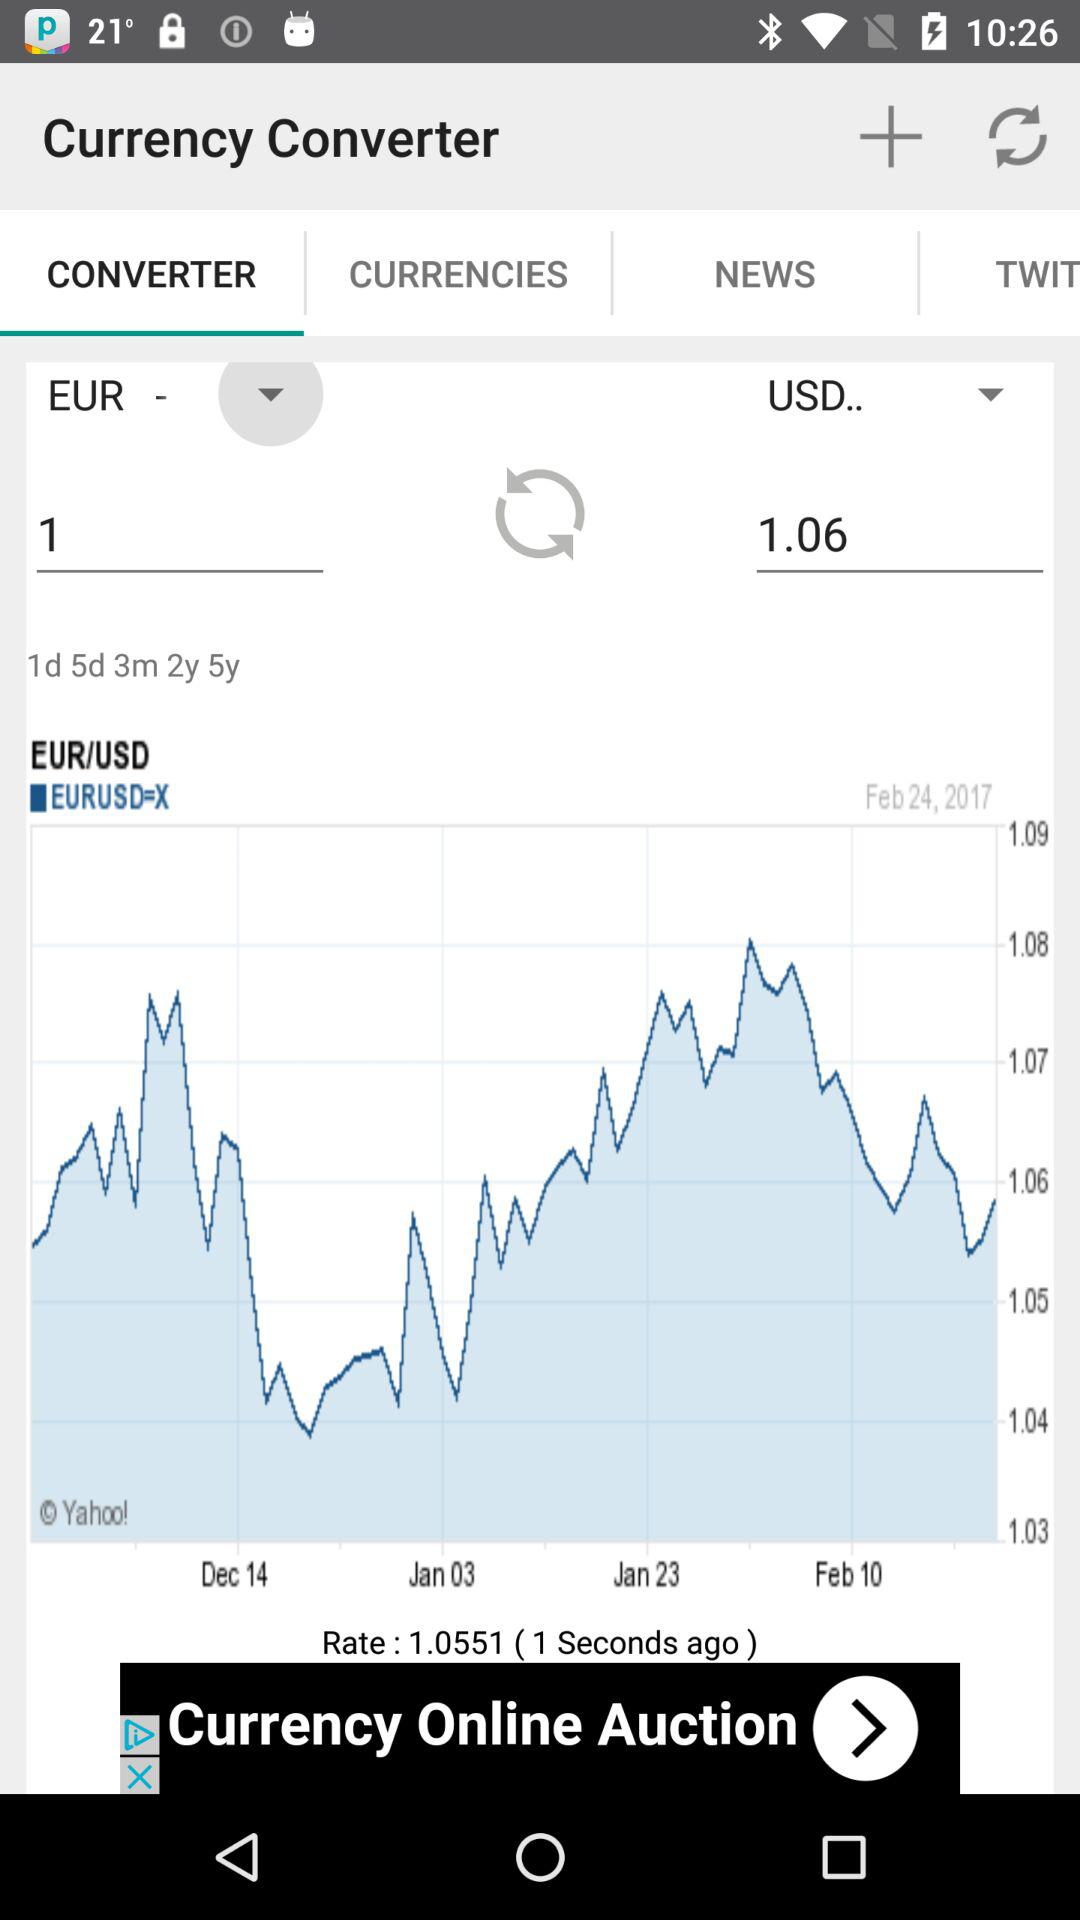How much is 1 EUR in USD on February 8, 2017?
When the provided information is insufficient, respond with <no answer>. <no answer> 